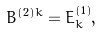<formula> <loc_0><loc_0><loc_500><loc_500>B ^ { ( 2 ) k } = E _ { k } ^ { ( 1 ) } ,</formula> 